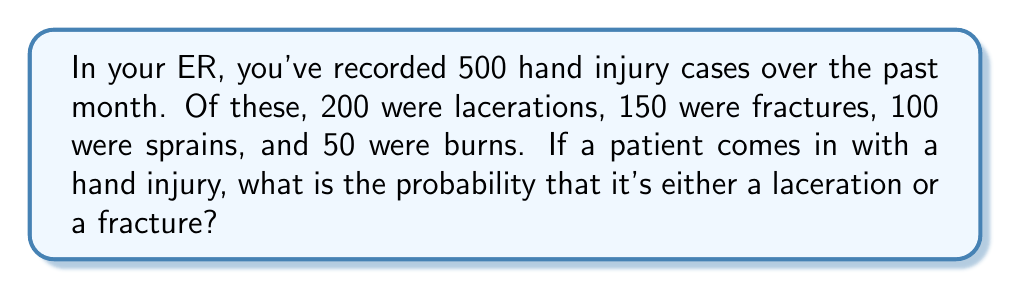Teach me how to tackle this problem. Let's approach this step-by-step:

1) First, we need to identify the total number of hand injury cases and the number of cases for the injury types we're interested in:

   Total hand injury cases: 500
   Lacerations: 200
   Fractures: 150

2) To find the probability of either a laceration or a fracture, we need to add their individual probabilities. This is because these events are mutually exclusive (a single injury can't be both a laceration and a fracture).

3) Probability of a laceration:
   $P(\text{Laceration}) = \frac{\text{Number of Lacerations}}{\text{Total Cases}} = \frac{200}{500} = 0.4$

4) Probability of a fracture:
   $P(\text{Fracture}) = \frac{\text{Number of Fractures}}{\text{Total Cases}} = \frac{150}{500} = 0.3$

5) Probability of either a laceration or a fracture:
   $P(\text{Laceration or Fracture}) = P(\text{Laceration}) + P(\text{Fracture})$
   $= 0.4 + 0.3 = 0.7$

6) We can also calculate this directly:
   $P(\text{Laceration or Fracture}) = \frac{\text{Lacerations + Fractures}}{\text{Total Cases}} = \frac{200 + 150}{500} = \frac{350}{500} = 0.7$

Therefore, the probability that a hand injury is either a laceration or a fracture is 0.7 or 70%.
Answer: 0.7 